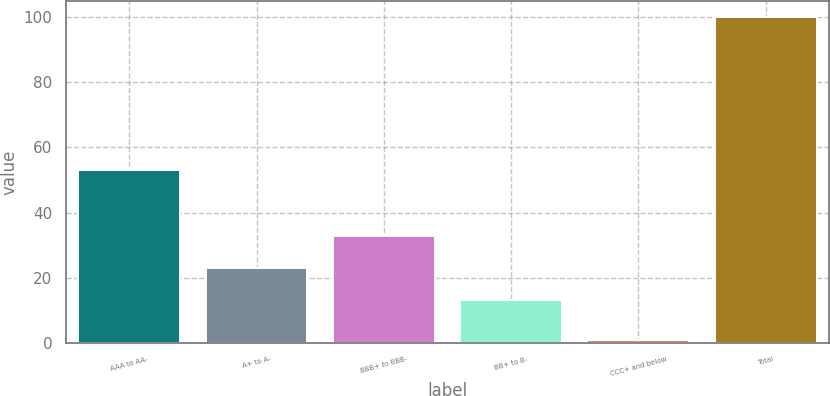<chart> <loc_0><loc_0><loc_500><loc_500><bar_chart><fcel>AAA to AA-<fcel>A+ to A-<fcel>BBB+ to BBB-<fcel>BB+ to B-<fcel>CCC+ and below<fcel>Total<nl><fcel>53<fcel>22.9<fcel>32.8<fcel>13<fcel>1<fcel>100<nl></chart> 